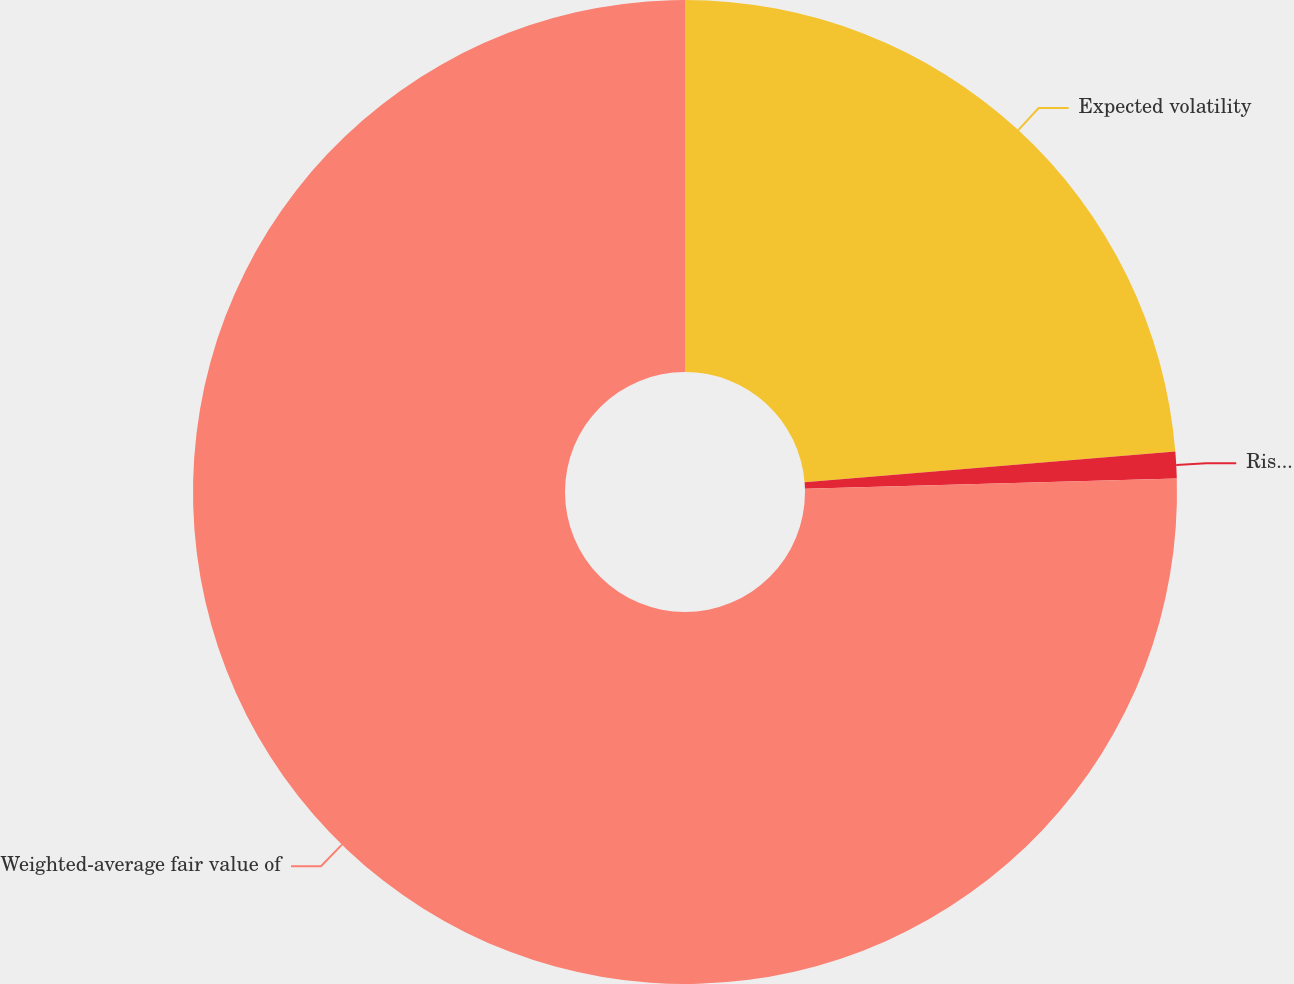Convert chart. <chart><loc_0><loc_0><loc_500><loc_500><pie_chart><fcel>Expected volatility<fcel>Risk-free interest rate<fcel>Weighted-average fair value of<nl><fcel>23.69%<fcel>0.87%<fcel>75.44%<nl></chart> 